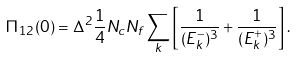<formula> <loc_0><loc_0><loc_500><loc_500>\Pi _ { 1 2 } ( 0 ) = \Delta ^ { 2 } \frac { 1 } { 4 } N _ { c } N _ { f } \sum _ { k } \left [ \frac { 1 } { ( E _ { k } ^ { - } ) ^ { 3 } } + \frac { 1 } { ( E _ { k } ^ { + } ) ^ { 3 } } \right ] .</formula> 